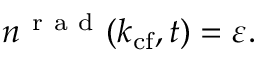Convert formula to latex. <formula><loc_0><loc_0><loc_500><loc_500>n ^ { r a d } ( k _ { c f } , t ) = \varepsilon .</formula> 